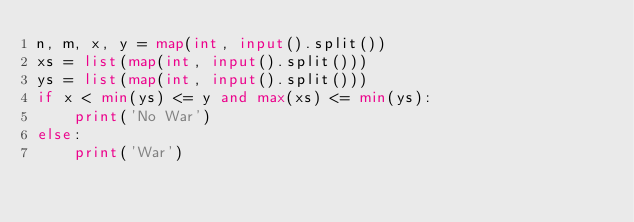Convert code to text. <code><loc_0><loc_0><loc_500><loc_500><_Python_>n, m, x, y = map(int, input().split())
xs = list(map(int, input().split()))
ys = list(map(int, input().split()))
if x < min(ys) <= y and max(xs) <= min(ys):
    print('No War')
else:
    print('War')</code> 